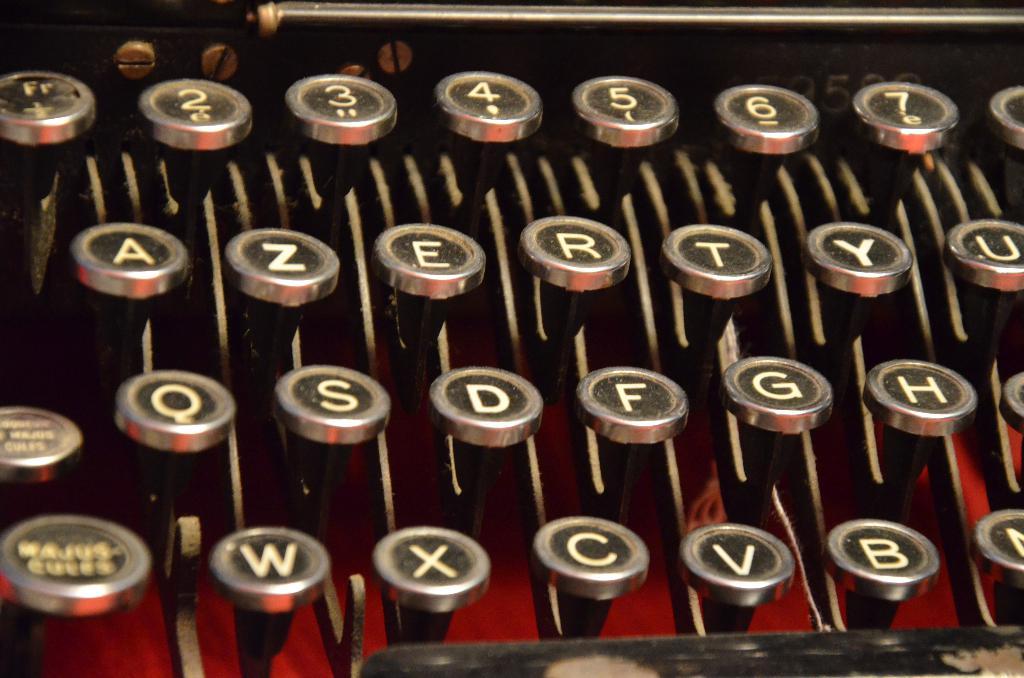What letter is to the left of z?
Your answer should be very brief. A. 